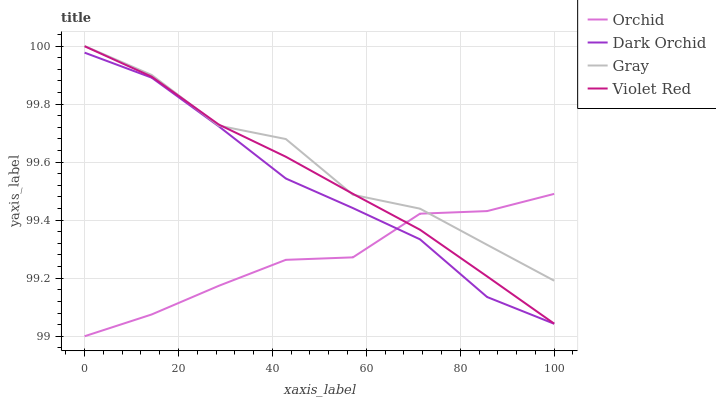Does Orchid have the minimum area under the curve?
Answer yes or no. Yes. Does Gray have the maximum area under the curve?
Answer yes or no. Yes. Does Violet Red have the minimum area under the curve?
Answer yes or no. No. Does Violet Red have the maximum area under the curve?
Answer yes or no. No. Is Violet Red the smoothest?
Answer yes or no. Yes. Is Gray the roughest?
Answer yes or no. Yes. Is Dark Orchid the smoothest?
Answer yes or no. No. Is Dark Orchid the roughest?
Answer yes or no. No. Does Orchid have the lowest value?
Answer yes or no. Yes. Does Violet Red have the lowest value?
Answer yes or no. No. Does Gray have the highest value?
Answer yes or no. Yes. Does Violet Red have the highest value?
Answer yes or no. No. Is Dark Orchid less than Gray?
Answer yes or no. Yes. Is Violet Red greater than Dark Orchid?
Answer yes or no. Yes. Does Gray intersect Orchid?
Answer yes or no. Yes. Is Gray less than Orchid?
Answer yes or no. No. Is Gray greater than Orchid?
Answer yes or no. No. Does Dark Orchid intersect Gray?
Answer yes or no. No. 